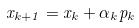Convert formula to latex. <formula><loc_0><loc_0><loc_500><loc_500>x _ { k + 1 } = x _ { k } + \alpha _ { k } p _ { k }</formula> 